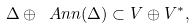Convert formula to latex. <formula><loc_0><loc_0><loc_500><loc_500>\Delta \oplus \ A n n ( \Delta ) \subset V \oplus V ^ { * } ,</formula> 